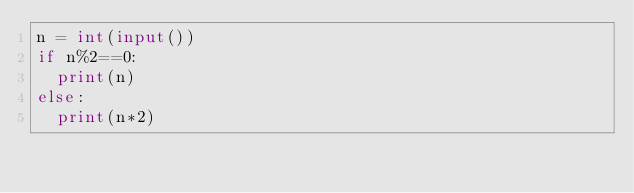Convert code to text. <code><loc_0><loc_0><loc_500><loc_500><_Python_>n = int(input())
if n%2==0:
  print(n)
else:
  print(n*2)</code> 